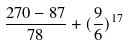<formula> <loc_0><loc_0><loc_500><loc_500>\frac { 2 7 0 - 8 7 } { 7 8 } + ( \frac { 9 } { 6 } ) ^ { 1 7 }</formula> 